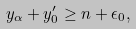Convert formula to latex. <formula><loc_0><loc_0><loc_500><loc_500>y _ { \alpha } + y ^ { \prime } _ { 0 } \geq n + \epsilon _ { 0 } ,</formula> 